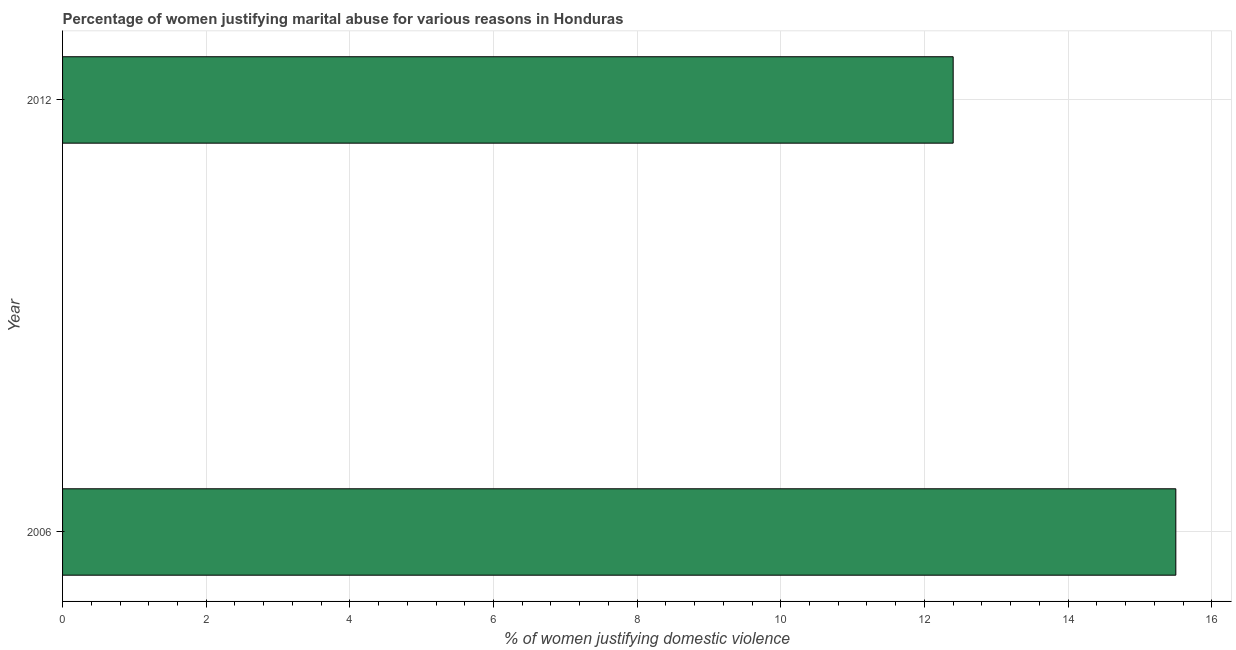What is the title of the graph?
Ensure brevity in your answer.  Percentage of women justifying marital abuse for various reasons in Honduras. What is the label or title of the X-axis?
Offer a terse response. % of women justifying domestic violence. What is the percentage of women justifying marital abuse in 2012?
Provide a short and direct response. 12.4. Across all years, what is the maximum percentage of women justifying marital abuse?
Provide a short and direct response. 15.5. In which year was the percentage of women justifying marital abuse maximum?
Your answer should be very brief. 2006. What is the sum of the percentage of women justifying marital abuse?
Ensure brevity in your answer.  27.9. What is the difference between the percentage of women justifying marital abuse in 2006 and 2012?
Offer a very short reply. 3.1. What is the average percentage of women justifying marital abuse per year?
Provide a succinct answer. 13.95. What is the median percentage of women justifying marital abuse?
Offer a terse response. 13.95. In how many years, is the percentage of women justifying marital abuse greater than 12.8 %?
Ensure brevity in your answer.  1. Do a majority of the years between 2006 and 2012 (inclusive) have percentage of women justifying marital abuse greater than 5.2 %?
Make the answer very short. Yes. What is the ratio of the percentage of women justifying marital abuse in 2006 to that in 2012?
Your answer should be very brief. 1.25. How many years are there in the graph?
Keep it short and to the point. 2. What is the difference between the % of women justifying domestic violence in 2006 and 2012?
Offer a very short reply. 3.1. What is the ratio of the % of women justifying domestic violence in 2006 to that in 2012?
Provide a short and direct response. 1.25. 